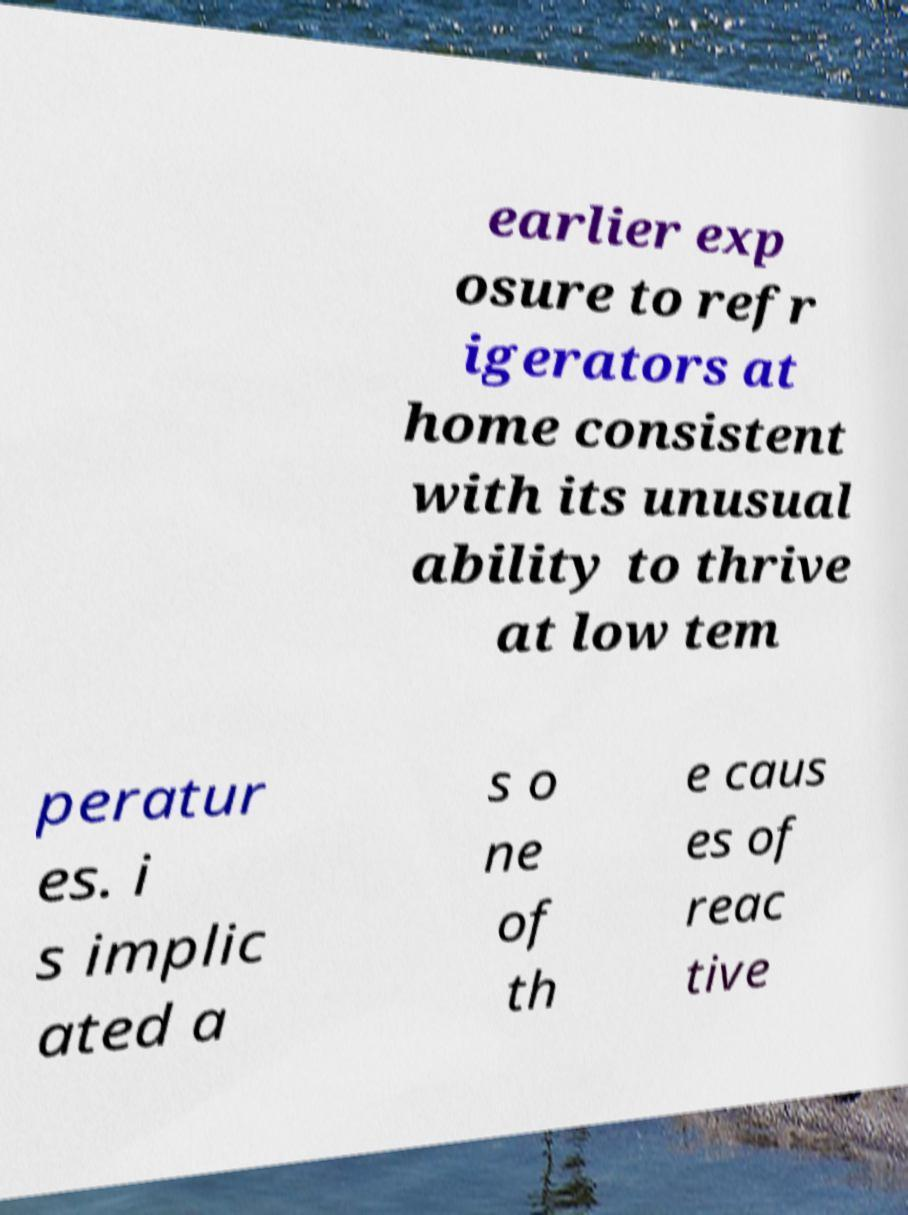There's text embedded in this image that I need extracted. Can you transcribe it verbatim? earlier exp osure to refr igerators at home consistent with its unusual ability to thrive at low tem peratur es. i s implic ated a s o ne of th e caus es of reac tive 